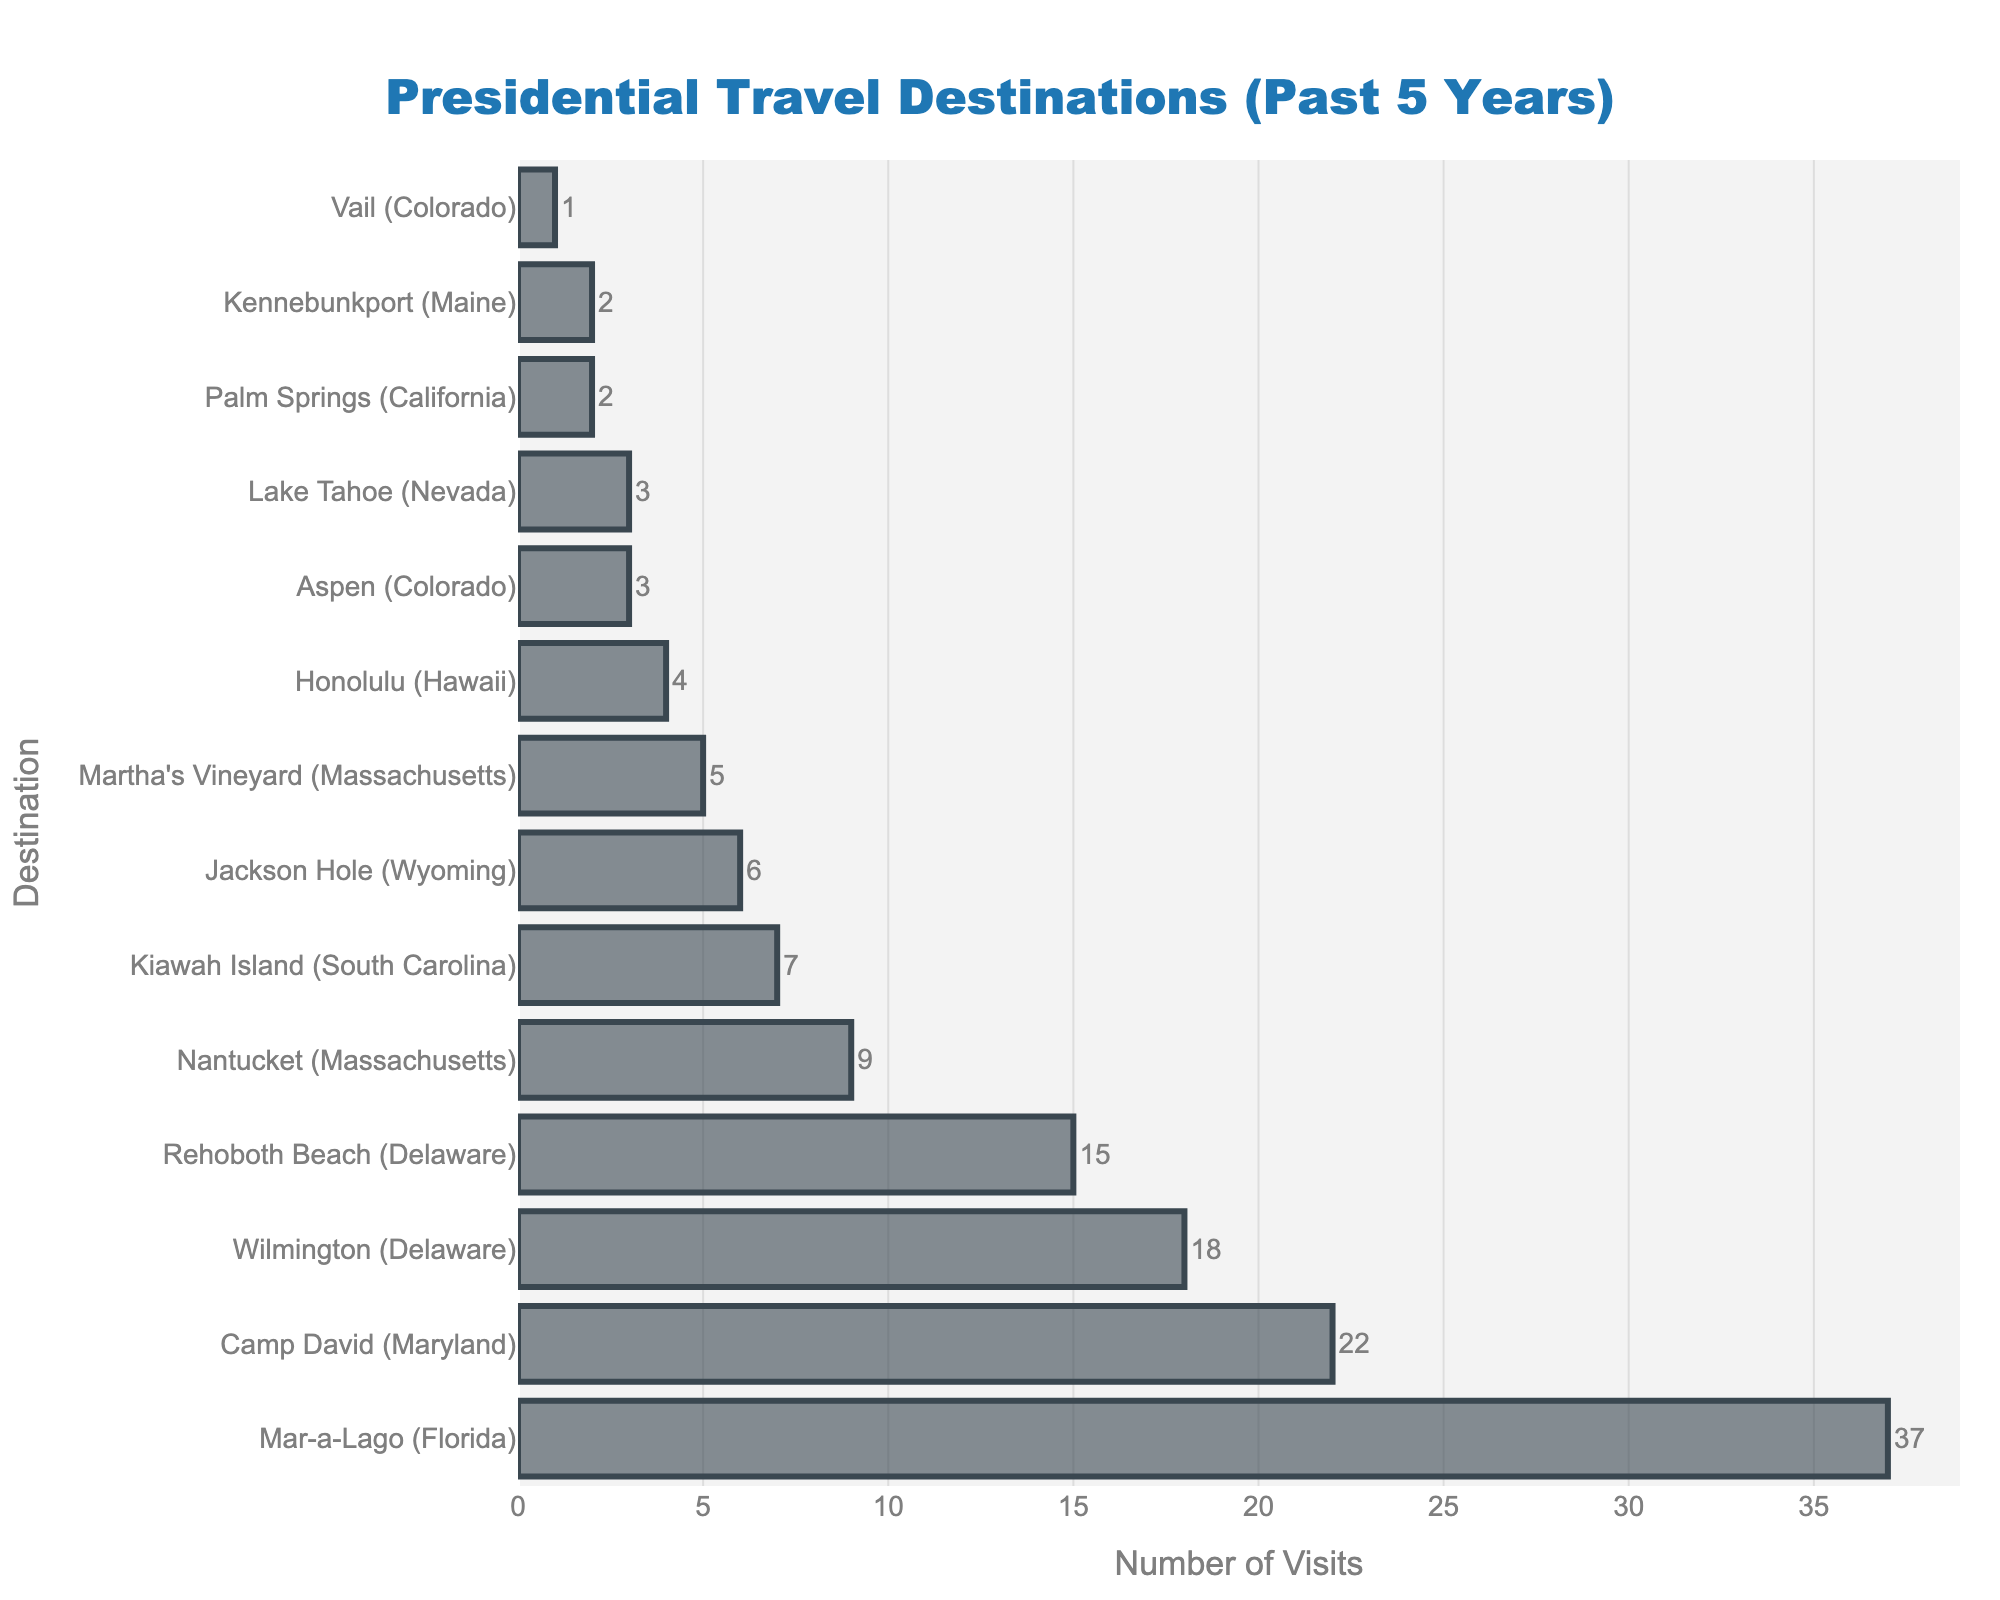What's the most visited destination? The bar representing Mar-a-Lago (Florida) is the longest, making it the most visited destination. The X-axis label shows 37 visits.
Answer: Mar-a-Lago (Florida) Which destination has fewer visits: Aspen (Colorado) or Kennebunkport (Maine)? The bars representing both Aspen (Colorado) and Kennebunkport (Maine) are relatively short, showing 3 and 2 visits, respectively. By comparing, Aspen (Colorado) has more visits than Kennebunkport (Maine).
Answer: Kennebunkport (Maine) How many total visits were made to the top three destinations combined? The top three destinations are Mar-a-Lago (Florida) with 37 visits, Camp David (Maryland) with 22 visits, and Wilmington (Delaware) with 18 visits. Adding these up: 37 + 22 + 18 = 77.
Answer: 77 What's the difference in the number of visits between Nantucket (Massachusetts) and Jackson Hole (Wyoming)? Nantucket (Massachusetts) has 9 visits, and Jackson Hole (Wyoming) has 6 visits. Subtracting Jackson Hole (Wyoming) from Nantucket (Massachusetts): 9 - 6 = 3.
Answer: 3 Which destination has more visits: Rehoboth Beach (Delaware) or Wilmington (Delaware)? Rehoboth Beach (Delaware) has 15 visits while Wilmington (Delaware) has 18 visits. Therefore, Wilmington (Delaware) has more visits.
Answer: Wilmington (Delaware) What's the least visited destination? The shortest bar represents Vail (Colorado) in the chart, showing it has the fewest visits, which is 1.
Answer: Vail (Colorado) What is the average number of visits for all destinations? Sum all visits from the destinations (37 + 22 + 18 + 15 + 9 + 7 + 6 + 5 + 4 + 3 + 3 + 2 + 2 + 1 = 134). There are 14 destinations, so divide the total visits by the number of destinations: 134 / 14 ≈ 9.57.
Answer: 9.57 What's the median number of visits among all destinations? Sorting the number of visits in ascending order: 1, 2, 2, 3, 3, 4, 5, 6, 7, 9, 15, 18, 22, 37. There are 14 values, so the median will be the average of the 7th and 8th values: (5 + 6) / 2 = 5.5.
Answer: 5.5 How many more visits does Mar-a-Lago (Florida) have compared to the eighth most visited destination? The eighth most visited destination is Martha's Vineyard (Massachusetts) with 5 visits. Mar-a-Lago (Florida) has 37 visits. Subtracting the visits of the eighth most visited: 37 - 5 = 32.
Answer: 32 